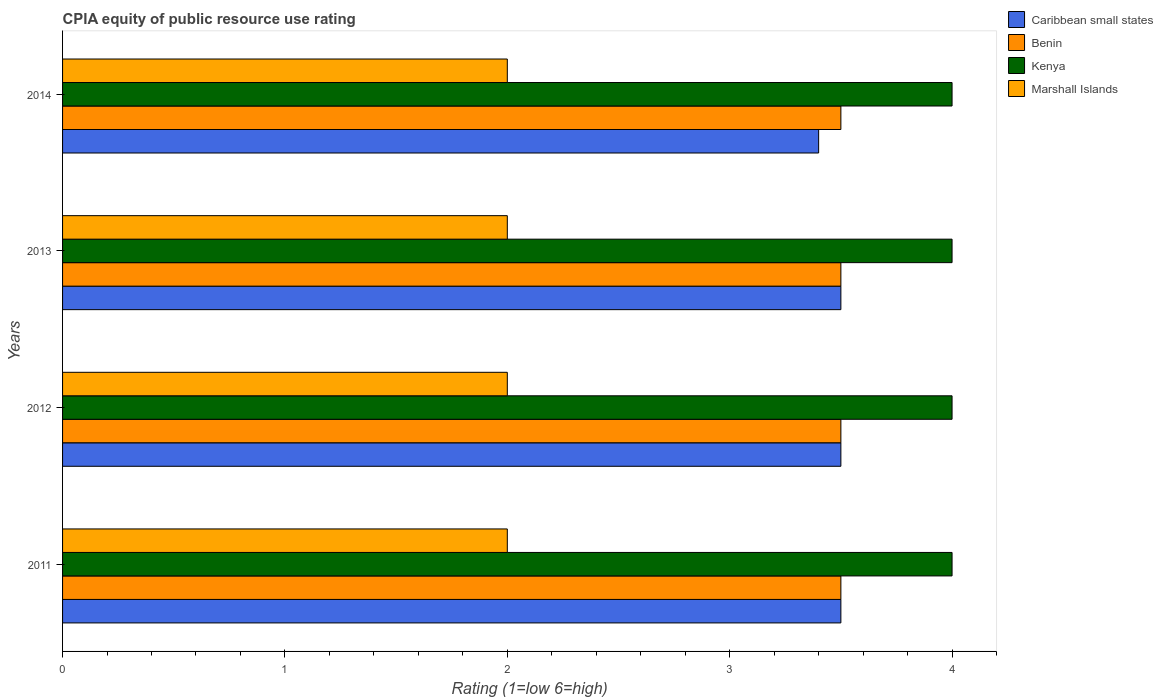How many different coloured bars are there?
Make the answer very short. 4. How many groups of bars are there?
Ensure brevity in your answer.  4. Are the number of bars on each tick of the Y-axis equal?
Your response must be concise. Yes. How many bars are there on the 2nd tick from the top?
Your answer should be compact. 4. How many bars are there on the 1st tick from the bottom?
Provide a succinct answer. 4. What is the label of the 3rd group of bars from the top?
Provide a succinct answer. 2012. In how many cases, is the number of bars for a given year not equal to the number of legend labels?
Ensure brevity in your answer.  0. What is the CPIA rating in Caribbean small states in 2014?
Ensure brevity in your answer.  3.4. In which year was the CPIA rating in Caribbean small states maximum?
Your response must be concise. 2011. What is the difference between the CPIA rating in Marshall Islands in 2011 and that in 2012?
Ensure brevity in your answer.  0. What is the difference between the CPIA rating in Benin in 2014 and the CPIA rating in Marshall Islands in 2013?
Keep it short and to the point. 1.5. Is the CPIA rating in Benin in 2011 less than that in 2013?
Keep it short and to the point. No. Is the difference between the CPIA rating in Marshall Islands in 2011 and 2012 greater than the difference between the CPIA rating in Benin in 2011 and 2012?
Provide a succinct answer. No. What is the difference between the highest and the second highest CPIA rating in Marshall Islands?
Give a very brief answer. 0. What is the difference between the highest and the lowest CPIA rating in Benin?
Offer a terse response. 0. In how many years, is the CPIA rating in Kenya greater than the average CPIA rating in Kenya taken over all years?
Provide a short and direct response. 0. Is the sum of the CPIA rating in Marshall Islands in 2011 and 2013 greater than the maximum CPIA rating in Benin across all years?
Your answer should be very brief. Yes. What does the 3rd bar from the top in 2011 represents?
Your answer should be very brief. Benin. What does the 3rd bar from the bottom in 2011 represents?
Provide a short and direct response. Kenya. Is it the case that in every year, the sum of the CPIA rating in Caribbean small states and CPIA rating in Benin is greater than the CPIA rating in Kenya?
Ensure brevity in your answer.  Yes. Does the graph contain any zero values?
Your response must be concise. No. Does the graph contain grids?
Your answer should be compact. No. Where does the legend appear in the graph?
Provide a succinct answer. Top right. How many legend labels are there?
Make the answer very short. 4. How are the legend labels stacked?
Offer a terse response. Vertical. What is the title of the graph?
Provide a short and direct response. CPIA equity of public resource use rating. What is the label or title of the Y-axis?
Your answer should be very brief. Years. What is the Rating (1=low 6=high) of Benin in 2011?
Offer a very short reply. 3.5. What is the Rating (1=low 6=high) in Kenya in 2011?
Offer a very short reply. 4. What is the Rating (1=low 6=high) of Marshall Islands in 2011?
Provide a succinct answer. 2. What is the Rating (1=low 6=high) of Caribbean small states in 2012?
Keep it short and to the point. 3.5. What is the Rating (1=low 6=high) in Kenya in 2012?
Keep it short and to the point. 4. What is the Rating (1=low 6=high) of Kenya in 2013?
Keep it short and to the point. 4. What is the Rating (1=low 6=high) of Marshall Islands in 2013?
Provide a short and direct response. 2. What is the Rating (1=low 6=high) of Caribbean small states in 2014?
Your answer should be compact. 3.4. What is the Rating (1=low 6=high) of Marshall Islands in 2014?
Provide a succinct answer. 2. Across all years, what is the maximum Rating (1=low 6=high) in Caribbean small states?
Make the answer very short. 3.5. Across all years, what is the maximum Rating (1=low 6=high) of Benin?
Offer a terse response. 3.5. Across all years, what is the maximum Rating (1=low 6=high) of Marshall Islands?
Your response must be concise. 2. Across all years, what is the minimum Rating (1=low 6=high) of Caribbean small states?
Offer a very short reply. 3.4. Across all years, what is the minimum Rating (1=low 6=high) in Kenya?
Make the answer very short. 4. Across all years, what is the minimum Rating (1=low 6=high) in Marshall Islands?
Your response must be concise. 2. What is the total Rating (1=low 6=high) of Benin in the graph?
Ensure brevity in your answer.  14. What is the total Rating (1=low 6=high) in Kenya in the graph?
Offer a terse response. 16. What is the difference between the Rating (1=low 6=high) of Caribbean small states in 2011 and that in 2013?
Give a very brief answer. 0. What is the difference between the Rating (1=low 6=high) of Benin in 2011 and that in 2013?
Offer a very short reply. 0. What is the difference between the Rating (1=low 6=high) in Kenya in 2011 and that in 2013?
Your answer should be very brief. 0. What is the difference between the Rating (1=low 6=high) of Marshall Islands in 2011 and that in 2013?
Ensure brevity in your answer.  0. What is the difference between the Rating (1=low 6=high) of Benin in 2011 and that in 2014?
Keep it short and to the point. 0. What is the difference between the Rating (1=low 6=high) in Marshall Islands in 2011 and that in 2014?
Provide a succinct answer. 0. What is the difference between the Rating (1=low 6=high) of Kenya in 2012 and that in 2013?
Your response must be concise. 0. What is the difference between the Rating (1=low 6=high) in Marshall Islands in 2012 and that in 2013?
Provide a short and direct response. 0. What is the difference between the Rating (1=low 6=high) of Caribbean small states in 2012 and that in 2014?
Your response must be concise. 0.1. What is the difference between the Rating (1=low 6=high) of Benin in 2012 and that in 2014?
Give a very brief answer. 0. What is the difference between the Rating (1=low 6=high) in Kenya in 2012 and that in 2014?
Your answer should be compact. 0. What is the difference between the Rating (1=low 6=high) in Marshall Islands in 2012 and that in 2014?
Make the answer very short. 0. What is the difference between the Rating (1=low 6=high) in Caribbean small states in 2011 and the Rating (1=low 6=high) in Kenya in 2012?
Your answer should be compact. -0.5. What is the difference between the Rating (1=low 6=high) in Benin in 2011 and the Rating (1=low 6=high) in Kenya in 2012?
Your answer should be compact. -0.5. What is the difference between the Rating (1=low 6=high) in Benin in 2011 and the Rating (1=low 6=high) in Marshall Islands in 2012?
Keep it short and to the point. 1.5. What is the difference between the Rating (1=low 6=high) of Caribbean small states in 2011 and the Rating (1=low 6=high) of Benin in 2014?
Your response must be concise. 0. What is the difference between the Rating (1=low 6=high) of Kenya in 2011 and the Rating (1=low 6=high) of Marshall Islands in 2014?
Your answer should be compact. 2. What is the difference between the Rating (1=low 6=high) in Caribbean small states in 2012 and the Rating (1=low 6=high) in Benin in 2013?
Give a very brief answer. 0. What is the difference between the Rating (1=low 6=high) of Caribbean small states in 2012 and the Rating (1=low 6=high) of Kenya in 2013?
Give a very brief answer. -0.5. What is the difference between the Rating (1=low 6=high) of Caribbean small states in 2012 and the Rating (1=low 6=high) of Marshall Islands in 2013?
Your response must be concise. 1.5. What is the difference between the Rating (1=low 6=high) in Benin in 2012 and the Rating (1=low 6=high) in Marshall Islands in 2013?
Provide a short and direct response. 1.5. What is the difference between the Rating (1=low 6=high) of Kenya in 2012 and the Rating (1=low 6=high) of Marshall Islands in 2013?
Your answer should be very brief. 2. What is the difference between the Rating (1=low 6=high) of Caribbean small states in 2012 and the Rating (1=low 6=high) of Kenya in 2014?
Offer a very short reply. -0.5. What is the difference between the Rating (1=low 6=high) of Caribbean small states in 2012 and the Rating (1=low 6=high) of Marshall Islands in 2014?
Offer a terse response. 1.5. What is the difference between the Rating (1=low 6=high) in Benin in 2012 and the Rating (1=low 6=high) in Kenya in 2014?
Your response must be concise. -0.5. What is the difference between the Rating (1=low 6=high) of Benin in 2012 and the Rating (1=low 6=high) of Marshall Islands in 2014?
Ensure brevity in your answer.  1.5. What is the difference between the Rating (1=low 6=high) in Kenya in 2012 and the Rating (1=low 6=high) in Marshall Islands in 2014?
Offer a terse response. 2. What is the difference between the Rating (1=low 6=high) of Caribbean small states in 2013 and the Rating (1=low 6=high) of Benin in 2014?
Give a very brief answer. 0. What is the difference between the Rating (1=low 6=high) of Caribbean small states in 2013 and the Rating (1=low 6=high) of Kenya in 2014?
Your answer should be compact. -0.5. What is the difference between the Rating (1=low 6=high) in Benin in 2013 and the Rating (1=low 6=high) in Kenya in 2014?
Provide a short and direct response. -0.5. What is the average Rating (1=low 6=high) of Caribbean small states per year?
Make the answer very short. 3.48. What is the average Rating (1=low 6=high) of Benin per year?
Your response must be concise. 3.5. In the year 2011, what is the difference between the Rating (1=low 6=high) of Benin and Rating (1=low 6=high) of Kenya?
Your response must be concise. -0.5. In the year 2011, what is the difference between the Rating (1=low 6=high) of Benin and Rating (1=low 6=high) of Marshall Islands?
Your answer should be very brief. 1.5. In the year 2011, what is the difference between the Rating (1=low 6=high) of Kenya and Rating (1=low 6=high) of Marshall Islands?
Offer a very short reply. 2. In the year 2013, what is the difference between the Rating (1=low 6=high) in Caribbean small states and Rating (1=low 6=high) in Kenya?
Provide a short and direct response. -0.5. In the year 2013, what is the difference between the Rating (1=low 6=high) in Benin and Rating (1=low 6=high) in Kenya?
Your answer should be very brief. -0.5. In the year 2014, what is the difference between the Rating (1=low 6=high) of Caribbean small states and Rating (1=low 6=high) of Benin?
Make the answer very short. -0.1. In the year 2014, what is the difference between the Rating (1=low 6=high) in Caribbean small states and Rating (1=low 6=high) in Kenya?
Provide a short and direct response. -0.6. In the year 2014, what is the difference between the Rating (1=low 6=high) of Benin and Rating (1=low 6=high) of Marshall Islands?
Keep it short and to the point. 1.5. What is the ratio of the Rating (1=low 6=high) of Benin in 2011 to that in 2012?
Provide a succinct answer. 1. What is the ratio of the Rating (1=low 6=high) of Benin in 2011 to that in 2013?
Provide a short and direct response. 1. What is the ratio of the Rating (1=low 6=high) of Marshall Islands in 2011 to that in 2013?
Keep it short and to the point. 1. What is the ratio of the Rating (1=low 6=high) of Caribbean small states in 2011 to that in 2014?
Keep it short and to the point. 1.03. What is the ratio of the Rating (1=low 6=high) of Caribbean small states in 2012 to that in 2013?
Provide a short and direct response. 1. What is the ratio of the Rating (1=low 6=high) in Benin in 2012 to that in 2013?
Make the answer very short. 1. What is the ratio of the Rating (1=low 6=high) of Caribbean small states in 2012 to that in 2014?
Keep it short and to the point. 1.03. What is the ratio of the Rating (1=low 6=high) of Benin in 2012 to that in 2014?
Provide a short and direct response. 1. What is the ratio of the Rating (1=low 6=high) of Kenya in 2012 to that in 2014?
Provide a short and direct response. 1. What is the ratio of the Rating (1=low 6=high) of Marshall Islands in 2012 to that in 2014?
Offer a terse response. 1. What is the ratio of the Rating (1=low 6=high) of Caribbean small states in 2013 to that in 2014?
Keep it short and to the point. 1.03. What is the ratio of the Rating (1=low 6=high) of Benin in 2013 to that in 2014?
Offer a terse response. 1. What is the difference between the highest and the second highest Rating (1=low 6=high) of Kenya?
Ensure brevity in your answer.  0. What is the difference between the highest and the lowest Rating (1=low 6=high) in Kenya?
Keep it short and to the point. 0. What is the difference between the highest and the lowest Rating (1=low 6=high) in Marshall Islands?
Make the answer very short. 0. 